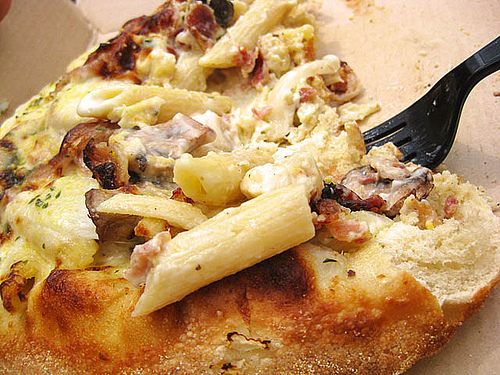<image>
Can you confirm if the macaroni is in the casserole? Yes. The macaroni is contained within or inside the casserole, showing a containment relationship. 